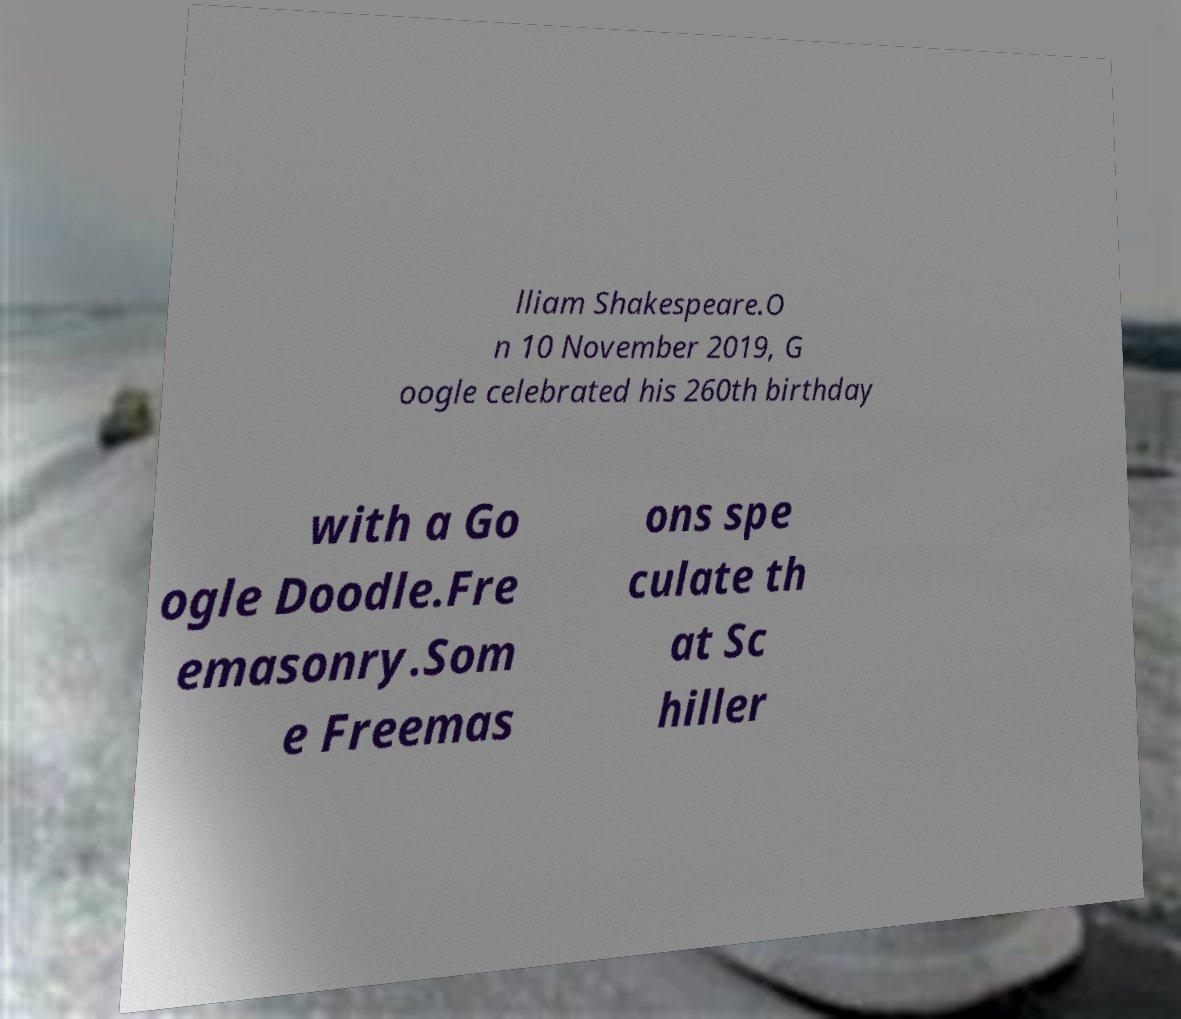For documentation purposes, I need the text within this image transcribed. Could you provide that? lliam Shakespeare.O n 10 November 2019, G oogle celebrated his 260th birthday with a Go ogle Doodle.Fre emasonry.Som e Freemas ons spe culate th at Sc hiller 